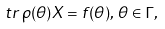<formula> <loc_0><loc_0><loc_500><loc_500>\ t r \, \rho ( \theta ) X = f ( \theta ) , \, \theta \in \Gamma ,</formula> 